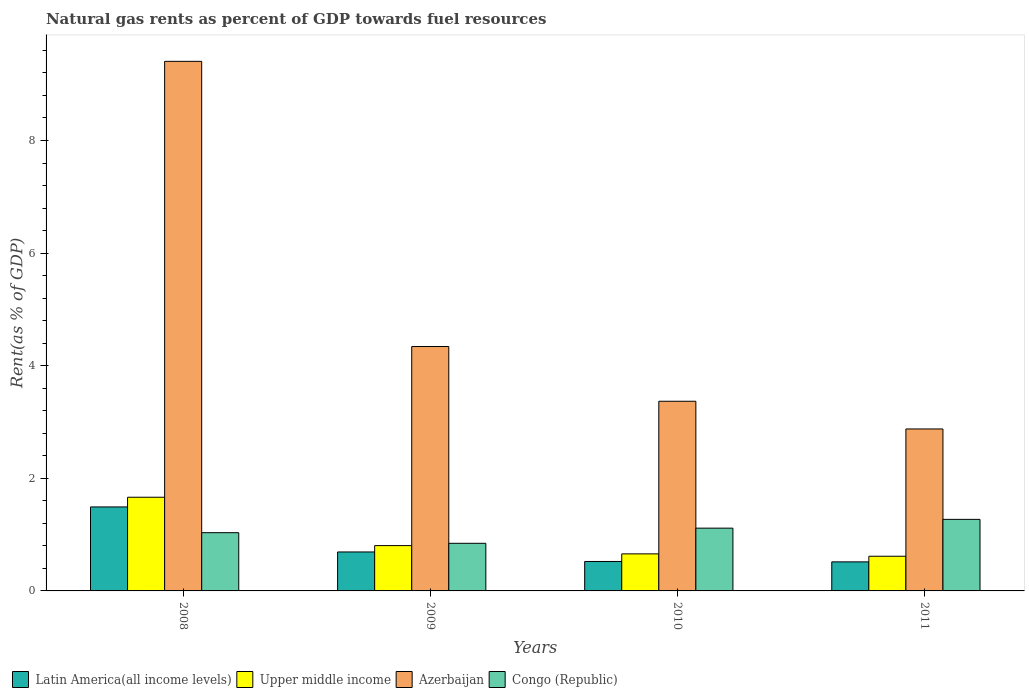Are the number of bars per tick equal to the number of legend labels?
Your answer should be very brief. Yes. How many bars are there on the 2nd tick from the left?
Provide a short and direct response. 4. How many bars are there on the 4th tick from the right?
Ensure brevity in your answer.  4. What is the label of the 1st group of bars from the left?
Make the answer very short. 2008. In how many cases, is the number of bars for a given year not equal to the number of legend labels?
Give a very brief answer. 0. What is the matural gas rent in Congo (Republic) in 2009?
Make the answer very short. 0.85. Across all years, what is the maximum matural gas rent in Azerbaijan?
Give a very brief answer. 9.41. Across all years, what is the minimum matural gas rent in Azerbaijan?
Keep it short and to the point. 2.88. What is the total matural gas rent in Upper middle income in the graph?
Ensure brevity in your answer.  3.74. What is the difference between the matural gas rent in Latin America(all income levels) in 2008 and that in 2009?
Give a very brief answer. 0.8. What is the difference between the matural gas rent in Latin America(all income levels) in 2008 and the matural gas rent in Upper middle income in 2010?
Make the answer very short. 0.83. What is the average matural gas rent in Latin America(all income levels) per year?
Make the answer very short. 0.81. In the year 2008, what is the difference between the matural gas rent in Upper middle income and matural gas rent in Latin America(all income levels)?
Offer a very short reply. 0.17. What is the ratio of the matural gas rent in Latin America(all income levels) in 2008 to that in 2011?
Your answer should be very brief. 2.89. What is the difference between the highest and the second highest matural gas rent in Azerbaijan?
Provide a succinct answer. 5.07. What is the difference between the highest and the lowest matural gas rent in Upper middle income?
Offer a terse response. 1.05. Is the sum of the matural gas rent in Azerbaijan in 2008 and 2011 greater than the maximum matural gas rent in Congo (Republic) across all years?
Ensure brevity in your answer.  Yes. Is it the case that in every year, the sum of the matural gas rent in Congo (Republic) and matural gas rent in Upper middle income is greater than the sum of matural gas rent in Latin America(all income levels) and matural gas rent in Azerbaijan?
Give a very brief answer. Yes. What does the 1st bar from the left in 2010 represents?
Your response must be concise. Latin America(all income levels). What does the 4th bar from the right in 2010 represents?
Offer a very short reply. Latin America(all income levels). Is it the case that in every year, the sum of the matural gas rent in Congo (Republic) and matural gas rent in Latin America(all income levels) is greater than the matural gas rent in Upper middle income?
Offer a very short reply. Yes. How many bars are there?
Your answer should be compact. 16. How many years are there in the graph?
Make the answer very short. 4. Are the values on the major ticks of Y-axis written in scientific E-notation?
Provide a succinct answer. No. Does the graph contain any zero values?
Make the answer very short. No. How are the legend labels stacked?
Keep it short and to the point. Horizontal. What is the title of the graph?
Ensure brevity in your answer.  Natural gas rents as percent of GDP towards fuel resources. Does "Gabon" appear as one of the legend labels in the graph?
Keep it short and to the point. No. What is the label or title of the Y-axis?
Your answer should be very brief. Rent(as % of GDP). What is the Rent(as % of GDP) in Latin America(all income levels) in 2008?
Your answer should be compact. 1.49. What is the Rent(as % of GDP) in Upper middle income in 2008?
Your answer should be very brief. 1.66. What is the Rent(as % of GDP) of Azerbaijan in 2008?
Provide a succinct answer. 9.41. What is the Rent(as % of GDP) of Congo (Republic) in 2008?
Give a very brief answer. 1.03. What is the Rent(as % of GDP) in Latin America(all income levels) in 2009?
Offer a very short reply. 0.69. What is the Rent(as % of GDP) of Upper middle income in 2009?
Make the answer very short. 0.8. What is the Rent(as % of GDP) in Azerbaijan in 2009?
Keep it short and to the point. 4.34. What is the Rent(as % of GDP) of Congo (Republic) in 2009?
Offer a terse response. 0.85. What is the Rent(as % of GDP) of Latin America(all income levels) in 2010?
Provide a succinct answer. 0.52. What is the Rent(as % of GDP) in Upper middle income in 2010?
Give a very brief answer. 0.66. What is the Rent(as % of GDP) of Azerbaijan in 2010?
Provide a short and direct response. 3.37. What is the Rent(as % of GDP) of Congo (Republic) in 2010?
Your answer should be very brief. 1.11. What is the Rent(as % of GDP) in Latin America(all income levels) in 2011?
Keep it short and to the point. 0.52. What is the Rent(as % of GDP) of Upper middle income in 2011?
Offer a terse response. 0.62. What is the Rent(as % of GDP) in Azerbaijan in 2011?
Ensure brevity in your answer.  2.88. What is the Rent(as % of GDP) of Congo (Republic) in 2011?
Keep it short and to the point. 1.27. Across all years, what is the maximum Rent(as % of GDP) in Latin America(all income levels)?
Offer a terse response. 1.49. Across all years, what is the maximum Rent(as % of GDP) in Upper middle income?
Make the answer very short. 1.66. Across all years, what is the maximum Rent(as % of GDP) of Azerbaijan?
Offer a very short reply. 9.41. Across all years, what is the maximum Rent(as % of GDP) in Congo (Republic)?
Provide a succinct answer. 1.27. Across all years, what is the minimum Rent(as % of GDP) of Latin America(all income levels)?
Your answer should be very brief. 0.52. Across all years, what is the minimum Rent(as % of GDP) of Upper middle income?
Give a very brief answer. 0.62. Across all years, what is the minimum Rent(as % of GDP) of Azerbaijan?
Provide a succinct answer. 2.88. Across all years, what is the minimum Rent(as % of GDP) of Congo (Republic)?
Your answer should be compact. 0.85. What is the total Rent(as % of GDP) in Latin America(all income levels) in the graph?
Your answer should be compact. 3.22. What is the total Rent(as % of GDP) of Upper middle income in the graph?
Your answer should be very brief. 3.74. What is the total Rent(as % of GDP) in Azerbaijan in the graph?
Your response must be concise. 19.99. What is the total Rent(as % of GDP) in Congo (Republic) in the graph?
Your answer should be very brief. 4.27. What is the difference between the Rent(as % of GDP) of Latin America(all income levels) in 2008 and that in 2009?
Your answer should be very brief. 0.8. What is the difference between the Rent(as % of GDP) of Upper middle income in 2008 and that in 2009?
Your answer should be very brief. 0.86. What is the difference between the Rent(as % of GDP) of Azerbaijan in 2008 and that in 2009?
Provide a succinct answer. 5.07. What is the difference between the Rent(as % of GDP) in Congo (Republic) in 2008 and that in 2009?
Your answer should be compact. 0.19. What is the difference between the Rent(as % of GDP) of Latin America(all income levels) in 2008 and that in 2010?
Your answer should be very brief. 0.97. What is the difference between the Rent(as % of GDP) in Upper middle income in 2008 and that in 2010?
Make the answer very short. 1.01. What is the difference between the Rent(as % of GDP) of Azerbaijan in 2008 and that in 2010?
Your answer should be very brief. 6.04. What is the difference between the Rent(as % of GDP) of Congo (Republic) in 2008 and that in 2010?
Make the answer very short. -0.08. What is the difference between the Rent(as % of GDP) of Latin America(all income levels) in 2008 and that in 2011?
Your answer should be very brief. 0.98. What is the difference between the Rent(as % of GDP) of Upper middle income in 2008 and that in 2011?
Your response must be concise. 1.05. What is the difference between the Rent(as % of GDP) in Azerbaijan in 2008 and that in 2011?
Give a very brief answer. 6.53. What is the difference between the Rent(as % of GDP) in Congo (Republic) in 2008 and that in 2011?
Make the answer very short. -0.24. What is the difference between the Rent(as % of GDP) in Latin America(all income levels) in 2009 and that in 2010?
Provide a succinct answer. 0.17. What is the difference between the Rent(as % of GDP) of Upper middle income in 2009 and that in 2010?
Your answer should be compact. 0.15. What is the difference between the Rent(as % of GDP) of Azerbaijan in 2009 and that in 2010?
Your answer should be very brief. 0.97. What is the difference between the Rent(as % of GDP) in Congo (Republic) in 2009 and that in 2010?
Ensure brevity in your answer.  -0.27. What is the difference between the Rent(as % of GDP) in Latin America(all income levels) in 2009 and that in 2011?
Offer a terse response. 0.18. What is the difference between the Rent(as % of GDP) of Upper middle income in 2009 and that in 2011?
Ensure brevity in your answer.  0.19. What is the difference between the Rent(as % of GDP) of Azerbaijan in 2009 and that in 2011?
Your answer should be very brief. 1.46. What is the difference between the Rent(as % of GDP) in Congo (Republic) in 2009 and that in 2011?
Provide a short and direct response. -0.43. What is the difference between the Rent(as % of GDP) in Latin America(all income levels) in 2010 and that in 2011?
Your answer should be very brief. 0.01. What is the difference between the Rent(as % of GDP) of Upper middle income in 2010 and that in 2011?
Offer a terse response. 0.04. What is the difference between the Rent(as % of GDP) in Azerbaijan in 2010 and that in 2011?
Give a very brief answer. 0.49. What is the difference between the Rent(as % of GDP) in Congo (Republic) in 2010 and that in 2011?
Provide a short and direct response. -0.16. What is the difference between the Rent(as % of GDP) of Latin America(all income levels) in 2008 and the Rent(as % of GDP) of Upper middle income in 2009?
Ensure brevity in your answer.  0.69. What is the difference between the Rent(as % of GDP) of Latin America(all income levels) in 2008 and the Rent(as % of GDP) of Azerbaijan in 2009?
Provide a short and direct response. -2.85. What is the difference between the Rent(as % of GDP) of Latin America(all income levels) in 2008 and the Rent(as % of GDP) of Congo (Republic) in 2009?
Provide a succinct answer. 0.65. What is the difference between the Rent(as % of GDP) of Upper middle income in 2008 and the Rent(as % of GDP) of Azerbaijan in 2009?
Your answer should be compact. -2.68. What is the difference between the Rent(as % of GDP) of Upper middle income in 2008 and the Rent(as % of GDP) of Congo (Republic) in 2009?
Offer a terse response. 0.82. What is the difference between the Rent(as % of GDP) in Azerbaijan in 2008 and the Rent(as % of GDP) in Congo (Republic) in 2009?
Provide a short and direct response. 8.56. What is the difference between the Rent(as % of GDP) in Latin America(all income levels) in 2008 and the Rent(as % of GDP) in Upper middle income in 2010?
Make the answer very short. 0.83. What is the difference between the Rent(as % of GDP) of Latin America(all income levels) in 2008 and the Rent(as % of GDP) of Azerbaijan in 2010?
Give a very brief answer. -1.88. What is the difference between the Rent(as % of GDP) of Latin America(all income levels) in 2008 and the Rent(as % of GDP) of Congo (Republic) in 2010?
Your answer should be very brief. 0.38. What is the difference between the Rent(as % of GDP) in Upper middle income in 2008 and the Rent(as % of GDP) in Azerbaijan in 2010?
Your response must be concise. -1.7. What is the difference between the Rent(as % of GDP) of Upper middle income in 2008 and the Rent(as % of GDP) of Congo (Republic) in 2010?
Offer a terse response. 0.55. What is the difference between the Rent(as % of GDP) in Azerbaijan in 2008 and the Rent(as % of GDP) in Congo (Republic) in 2010?
Make the answer very short. 8.29. What is the difference between the Rent(as % of GDP) in Latin America(all income levels) in 2008 and the Rent(as % of GDP) in Upper middle income in 2011?
Your answer should be very brief. 0.88. What is the difference between the Rent(as % of GDP) of Latin America(all income levels) in 2008 and the Rent(as % of GDP) of Azerbaijan in 2011?
Your answer should be compact. -1.39. What is the difference between the Rent(as % of GDP) in Latin America(all income levels) in 2008 and the Rent(as % of GDP) in Congo (Republic) in 2011?
Your response must be concise. 0.22. What is the difference between the Rent(as % of GDP) of Upper middle income in 2008 and the Rent(as % of GDP) of Azerbaijan in 2011?
Your answer should be very brief. -1.21. What is the difference between the Rent(as % of GDP) in Upper middle income in 2008 and the Rent(as % of GDP) in Congo (Republic) in 2011?
Provide a short and direct response. 0.39. What is the difference between the Rent(as % of GDP) in Azerbaijan in 2008 and the Rent(as % of GDP) in Congo (Republic) in 2011?
Your answer should be compact. 8.13. What is the difference between the Rent(as % of GDP) of Latin America(all income levels) in 2009 and the Rent(as % of GDP) of Upper middle income in 2010?
Provide a short and direct response. 0.03. What is the difference between the Rent(as % of GDP) of Latin America(all income levels) in 2009 and the Rent(as % of GDP) of Azerbaijan in 2010?
Your response must be concise. -2.68. What is the difference between the Rent(as % of GDP) of Latin America(all income levels) in 2009 and the Rent(as % of GDP) of Congo (Republic) in 2010?
Your answer should be very brief. -0.42. What is the difference between the Rent(as % of GDP) in Upper middle income in 2009 and the Rent(as % of GDP) in Azerbaijan in 2010?
Your answer should be compact. -2.56. What is the difference between the Rent(as % of GDP) of Upper middle income in 2009 and the Rent(as % of GDP) of Congo (Republic) in 2010?
Give a very brief answer. -0.31. What is the difference between the Rent(as % of GDP) in Azerbaijan in 2009 and the Rent(as % of GDP) in Congo (Republic) in 2010?
Offer a very short reply. 3.23. What is the difference between the Rent(as % of GDP) in Latin America(all income levels) in 2009 and the Rent(as % of GDP) in Upper middle income in 2011?
Your response must be concise. 0.08. What is the difference between the Rent(as % of GDP) in Latin America(all income levels) in 2009 and the Rent(as % of GDP) in Azerbaijan in 2011?
Keep it short and to the point. -2.18. What is the difference between the Rent(as % of GDP) in Latin America(all income levels) in 2009 and the Rent(as % of GDP) in Congo (Republic) in 2011?
Give a very brief answer. -0.58. What is the difference between the Rent(as % of GDP) in Upper middle income in 2009 and the Rent(as % of GDP) in Azerbaijan in 2011?
Make the answer very short. -2.07. What is the difference between the Rent(as % of GDP) of Upper middle income in 2009 and the Rent(as % of GDP) of Congo (Republic) in 2011?
Provide a succinct answer. -0.47. What is the difference between the Rent(as % of GDP) in Azerbaijan in 2009 and the Rent(as % of GDP) in Congo (Republic) in 2011?
Make the answer very short. 3.07. What is the difference between the Rent(as % of GDP) of Latin America(all income levels) in 2010 and the Rent(as % of GDP) of Upper middle income in 2011?
Provide a short and direct response. -0.09. What is the difference between the Rent(as % of GDP) in Latin America(all income levels) in 2010 and the Rent(as % of GDP) in Azerbaijan in 2011?
Keep it short and to the point. -2.35. What is the difference between the Rent(as % of GDP) in Latin America(all income levels) in 2010 and the Rent(as % of GDP) in Congo (Republic) in 2011?
Provide a short and direct response. -0.75. What is the difference between the Rent(as % of GDP) of Upper middle income in 2010 and the Rent(as % of GDP) of Azerbaijan in 2011?
Keep it short and to the point. -2.22. What is the difference between the Rent(as % of GDP) of Upper middle income in 2010 and the Rent(as % of GDP) of Congo (Republic) in 2011?
Keep it short and to the point. -0.61. What is the difference between the Rent(as % of GDP) of Azerbaijan in 2010 and the Rent(as % of GDP) of Congo (Republic) in 2011?
Your answer should be compact. 2.1. What is the average Rent(as % of GDP) of Latin America(all income levels) per year?
Your answer should be very brief. 0.81. What is the average Rent(as % of GDP) of Upper middle income per year?
Make the answer very short. 0.94. What is the average Rent(as % of GDP) in Azerbaijan per year?
Your answer should be compact. 5. What is the average Rent(as % of GDP) in Congo (Republic) per year?
Provide a succinct answer. 1.07. In the year 2008, what is the difference between the Rent(as % of GDP) in Latin America(all income levels) and Rent(as % of GDP) in Upper middle income?
Keep it short and to the point. -0.17. In the year 2008, what is the difference between the Rent(as % of GDP) of Latin America(all income levels) and Rent(as % of GDP) of Azerbaijan?
Offer a very short reply. -7.91. In the year 2008, what is the difference between the Rent(as % of GDP) of Latin America(all income levels) and Rent(as % of GDP) of Congo (Republic)?
Your answer should be compact. 0.46. In the year 2008, what is the difference between the Rent(as % of GDP) of Upper middle income and Rent(as % of GDP) of Azerbaijan?
Provide a succinct answer. -7.74. In the year 2008, what is the difference between the Rent(as % of GDP) of Upper middle income and Rent(as % of GDP) of Congo (Republic)?
Offer a terse response. 0.63. In the year 2008, what is the difference between the Rent(as % of GDP) of Azerbaijan and Rent(as % of GDP) of Congo (Republic)?
Give a very brief answer. 8.37. In the year 2009, what is the difference between the Rent(as % of GDP) in Latin America(all income levels) and Rent(as % of GDP) in Upper middle income?
Your answer should be very brief. -0.11. In the year 2009, what is the difference between the Rent(as % of GDP) of Latin America(all income levels) and Rent(as % of GDP) of Azerbaijan?
Provide a succinct answer. -3.65. In the year 2009, what is the difference between the Rent(as % of GDP) in Latin America(all income levels) and Rent(as % of GDP) in Congo (Republic)?
Provide a short and direct response. -0.15. In the year 2009, what is the difference between the Rent(as % of GDP) of Upper middle income and Rent(as % of GDP) of Azerbaijan?
Your answer should be very brief. -3.54. In the year 2009, what is the difference between the Rent(as % of GDP) in Upper middle income and Rent(as % of GDP) in Congo (Republic)?
Keep it short and to the point. -0.04. In the year 2009, what is the difference between the Rent(as % of GDP) in Azerbaijan and Rent(as % of GDP) in Congo (Republic)?
Your answer should be very brief. 3.5. In the year 2010, what is the difference between the Rent(as % of GDP) of Latin America(all income levels) and Rent(as % of GDP) of Upper middle income?
Provide a short and direct response. -0.14. In the year 2010, what is the difference between the Rent(as % of GDP) of Latin America(all income levels) and Rent(as % of GDP) of Azerbaijan?
Offer a very short reply. -2.85. In the year 2010, what is the difference between the Rent(as % of GDP) in Latin America(all income levels) and Rent(as % of GDP) in Congo (Republic)?
Your answer should be very brief. -0.59. In the year 2010, what is the difference between the Rent(as % of GDP) in Upper middle income and Rent(as % of GDP) in Azerbaijan?
Your answer should be very brief. -2.71. In the year 2010, what is the difference between the Rent(as % of GDP) in Upper middle income and Rent(as % of GDP) in Congo (Republic)?
Offer a very short reply. -0.46. In the year 2010, what is the difference between the Rent(as % of GDP) of Azerbaijan and Rent(as % of GDP) of Congo (Republic)?
Make the answer very short. 2.25. In the year 2011, what is the difference between the Rent(as % of GDP) in Latin America(all income levels) and Rent(as % of GDP) in Upper middle income?
Make the answer very short. -0.1. In the year 2011, what is the difference between the Rent(as % of GDP) in Latin America(all income levels) and Rent(as % of GDP) in Azerbaijan?
Offer a very short reply. -2.36. In the year 2011, what is the difference between the Rent(as % of GDP) in Latin America(all income levels) and Rent(as % of GDP) in Congo (Republic)?
Offer a very short reply. -0.76. In the year 2011, what is the difference between the Rent(as % of GDP) in Upper middle income and Rent(as % of GDP) in Azerbaijan?
Your answer should be very brief. -2.26. In the year 2011, what is the difference between the Rent(as % of GDP) of Upper middle income and Rent(as % of GDP) of Congo (Republic)?
Offer a terse response. -0.66. In the year 2011, what is the difference between the Rent(as % of GDP) in Azerbaijan and Rent(as % of GDP) in Congo (Republic)?
Provide a succinct answer. 1.61. What is the ratio of the Rent(as % of GDP) of Latin America(all income levels) in 2008 to that in 2009?
Your answer should be very brief. 2.16. What is the ratio of the Rent(as % of GDP) in Upper middle income in 2008 to that in 2009?
Offer a terse response. 2.07. What is the ratio of the Rent(as % of GDP) in Azerbaijan in 2008 to that in 2009?
Your answer should be compact. 2.17. What is the ratio of the Rent(as % of GDP) in Congo (Republic) in 2008 to that in 2009?
Your answer should be compact. 1.22. What is the ratio of the Rent(as % of GDP) in Latin America(all income levels) in 2008 to that in 2010?
Ensure brevity in your answer.  2.85. What is the ratio of the Rent(as % of GDP) in Upper middle income in 2008 to that in 2010?
Your answer should be very brief. 2.53. What is the ratio of the Rent(as % of GDP) of Azerbaijan in 2008 to that in 2010?
Ensure brevity in your answer.  2.79. What is the ratio of the Rent(as % of GDP) of Congo (Republic) in 2008 to that in 2010?
Make the answer very short. 0.93. What is the ratio of the Rent(as % of GDP) in Latin America(all income levels) in 2008 to that in 2011?
Ensure brevity in your answer.  2.89. What is the ratio of the Rent(as % of GDP) of Upper middle income in 2008 to that in 2011?
Keep it short and to the point. 2.7. What is the ratio of the Rent(as % of GDP) of Azerbaijan in 2008 to that in 2011?
Your answer should be very brief. 3.27. What is the ratio of the Rent(as % of GDP) in Congo (Republic) in 2008 to that in 2011?
Your response must be concise. 0.81. What is the ratio of the Rent(as % of GDP) in Latin America(all income levels) in 2009 to that in 2010?
Give a very brief answer. 1.32. What is the ratio of the Rent(as % of GDP) in Upper middle income in 2009 to that in 2010?
Make the answer very short. 1.22. What is the ratio of the Rent(as % of GDP) of Azerbaijan in 2009 to that in 2010?
Your response must be concise. 1.29. What is the ratio of the Rent(as % of GDP) in Congo (Republic) in 2009 to that in 2010?
Offer a terse response. 0.76. What is the ratio of the Rent(as % of GDP) of Latin America(all income levels) in 2009 to that in 2011?
Offer a very short reply. 1.34. What is the ratio of the Rent(as % of GDP) of Upper middle income in 2009 to that in 2011?
Provide a succinct answer. 1.31. What is the ratio of the Rent(as % of GDP) in Azerbaijan in 2009 to that in 2011?
Offer a terse response. 1.51. What is the ratio of the Rent(as % of GDP) in Congo (Republic) in 2009 to that in 2011?
Offer a terse response. 0.67. What is the ratio of the Rent(as % of GDP) of Latin America(all income levels) in 2010 to that in 2011?
Provide a succinct answer. 1.01. What is the ratio of the Rent(as % of GDP) in Upper middle income in 2010 to that in 2011?
Make the answer very short. 1.07. What is the ratio of the Rent(as % of GDP) of Azerbaijan in 2010 to that in 2011?
Keep it short and to the point. 1.17. What is the ratio of the Rent(as % of GDP) of Congo (Republic) in 2010 to that in 2011?
Your answer should be compact. 0.88. What is the difference between the highest and the second highest Rent(as % of GDP) in Latin America(all income levels)?
Offer a terse response. 0.8. What is the difference between the highest and the second highest Rent(as % of GDP) of Upper middle income?
Provide a short and direct response. 0.86. What is the difference between the highest and the second highest Rent(as % of GDP) of Azerbaijan?
Offer a terse response. 5.07. What is the difference between the highest and the second highest Rent(as % of GDP) of Congo (Republic)?
Provide a succinct answer. 0.16. What is the difference between the highest and the lowest Rent(as % of GDP) of Latin America(all income levels)?
Give a very brief answer. 0.98. What is the difference between the highest and the lowest Rent(as % of GDP) of Upper middle income?
Ensure brevity in your answer.  1.05. What is the difference between the highest and the lowest Rent(as % of GDP) in Azerbaijan?
Offer a very short reply. 6.53. What is the difference between the highest and the lowest Rent(as % of GDP) of Congo (Republic)?
Your answer should be compact. 0.43. 